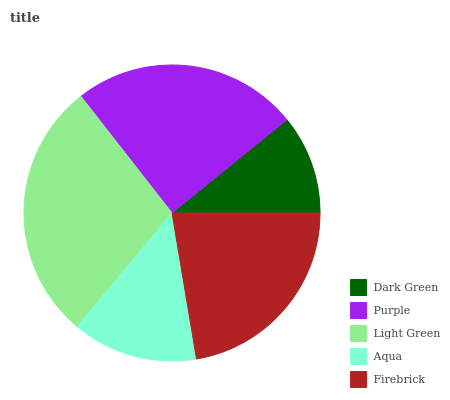Is Dark Green the minimum?
Answer yes or no. Yes. Is Light Green the maximum?
Answer yes or no. Yes. Is Purple the minimum?
Answer yes or no. No. Is Purple the maximum?
Answer yes or no. No. Is Purple greater than Dark Green?
Answer yes or no. Yes. Is Dark Green less than Purple?
Answer yes or no. Yes. Is Dark Green greater than Purple?
Answer yes or no. No. Is Purple less than Dark Green?
Answer yes or no. No. Is Firebrick the high median?
Answer yes or no. Yes. Is Firebrick the low median?
Answer yes or no. Yes. Is Purple the high median?
Answer yes or no. No. Is Purple the low median?
Answer yes or no. No. 